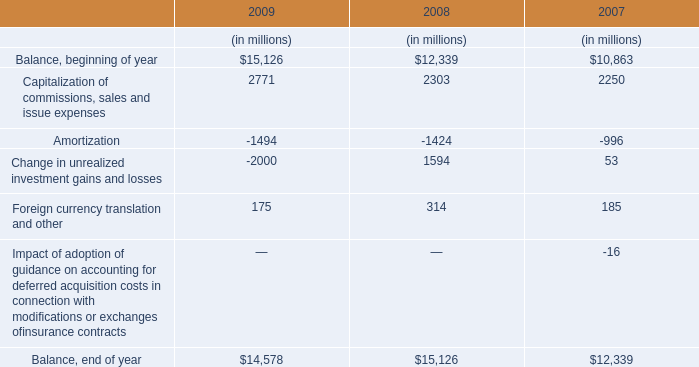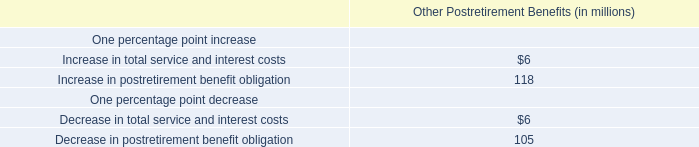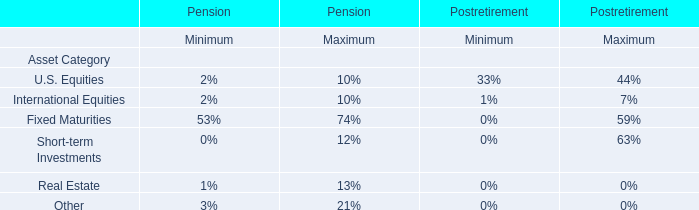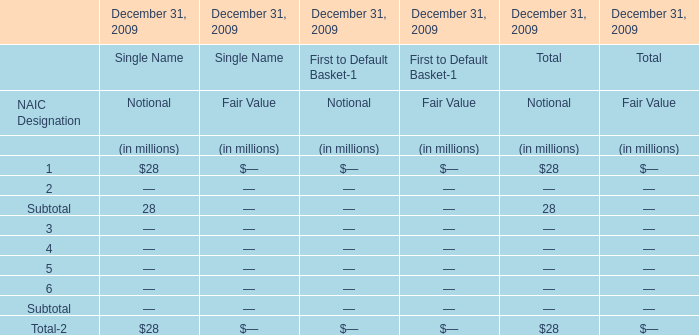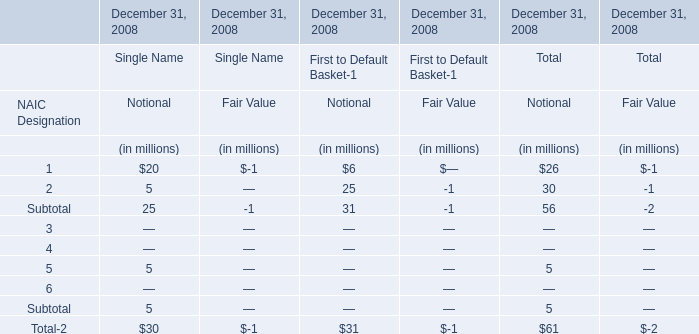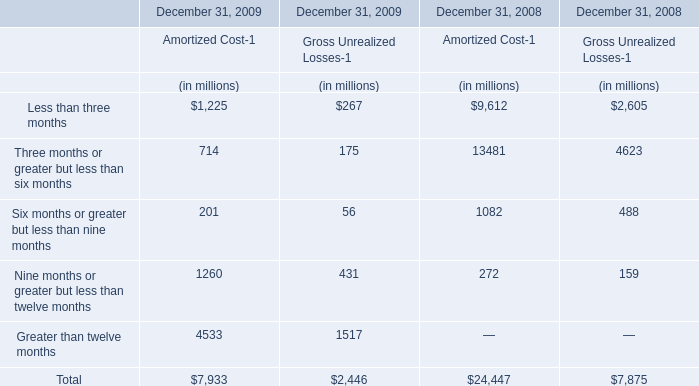What was the total amount of Gross Unrealized Losses-1 excluding those Gross Unrealized Losses-1 greater than 200 in 2009 ? (in million) 
Computations: (56 + 175)
Answer: 231.0. 